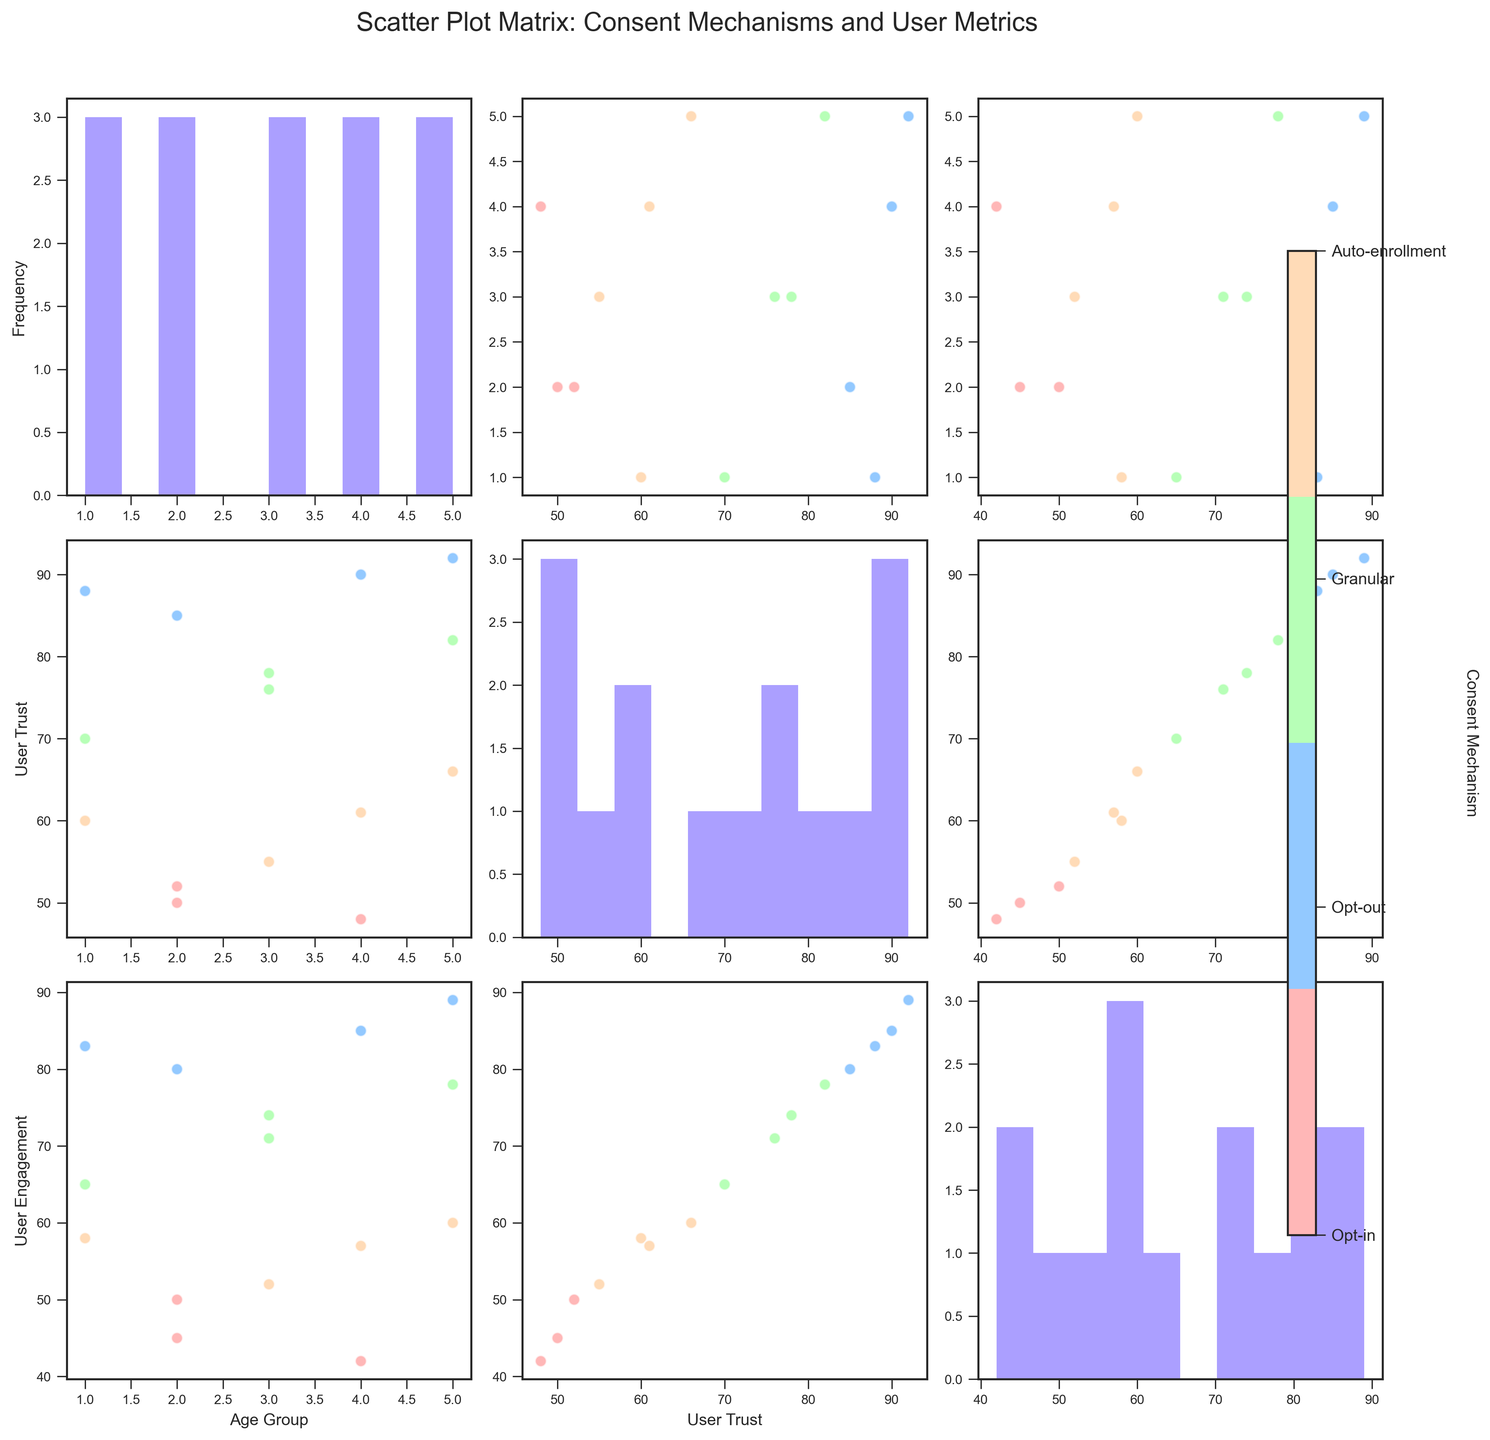what is the color representing the "Opt-in" consent mechanism? The color bar on the right side of the figure shows that the colors range from light to dark. By looking at the color bar label, Opt-in corresponds to the first position, which is light red.
Answer: light red What is the title of the figure? The figure's title is placed at the top and reads "Scatter Plot Matrix: Consent Mechanisms and User Metrics."
Answer: Scatter Plot Matrix: Consent Mechanisms and User Metrics Which age group has the highest user engagement? By examining the scatter plots involving user engagement, we can identify that the age group '46-60' consistently shows higher user engagement values compared to other age groups.
Answer: 46-60 Which consent mechanism has the widest range of user trust values? By comparing the scatter plots and histograms for user trust across different consent mechanisms, it is evident that granular consent mechanisms exhibit the widest range of values.
Answer: Granular How many unique age groups are represented in the figure? The y-axis of the scatter plots shows the 'Age Group' values mapped from '18-25' to '60+'. There are five age groups listed.
Answer: 5 Are there any age groups where auto-enrollment consistently results in low user trust? Observing the scatter plots for user trust, auto-enrollment seems to result in low trust values, particularly for the age groups '26-35' and '46-60'.
Answer: Yes How does user trust correlate with user engagement for granular consent mechanisms? Focusing on the scatter plots where the consent mechanism is granular and analyzing the values of user trust and user engagement, it can be seen that there is a strong positive correlation between the two.
Answer: Positive correlation Looking at the scatter plot of 'Age Group' vs 'User Engagement', in which age group does 'Opt-out' result in notably lower user engagement? The scatter plot indicates that for the age group '18-25', the opt-out mechanism results in relatively lower user engagement values.
Answer: 18-25 What is the color representing the highest user engagement in 'Granular' consent mechanism? By examining the scatter plots and referring to the color bar, the highest user engagement for granular consent mechanisms appears in the color corresponding to the last position, which is dark green.
Answer: Dark green 